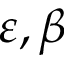Convert formula to latex. <formula><loc_0><loc_0><loc_500><loc_500>\varepsilon , \beta</formula> 